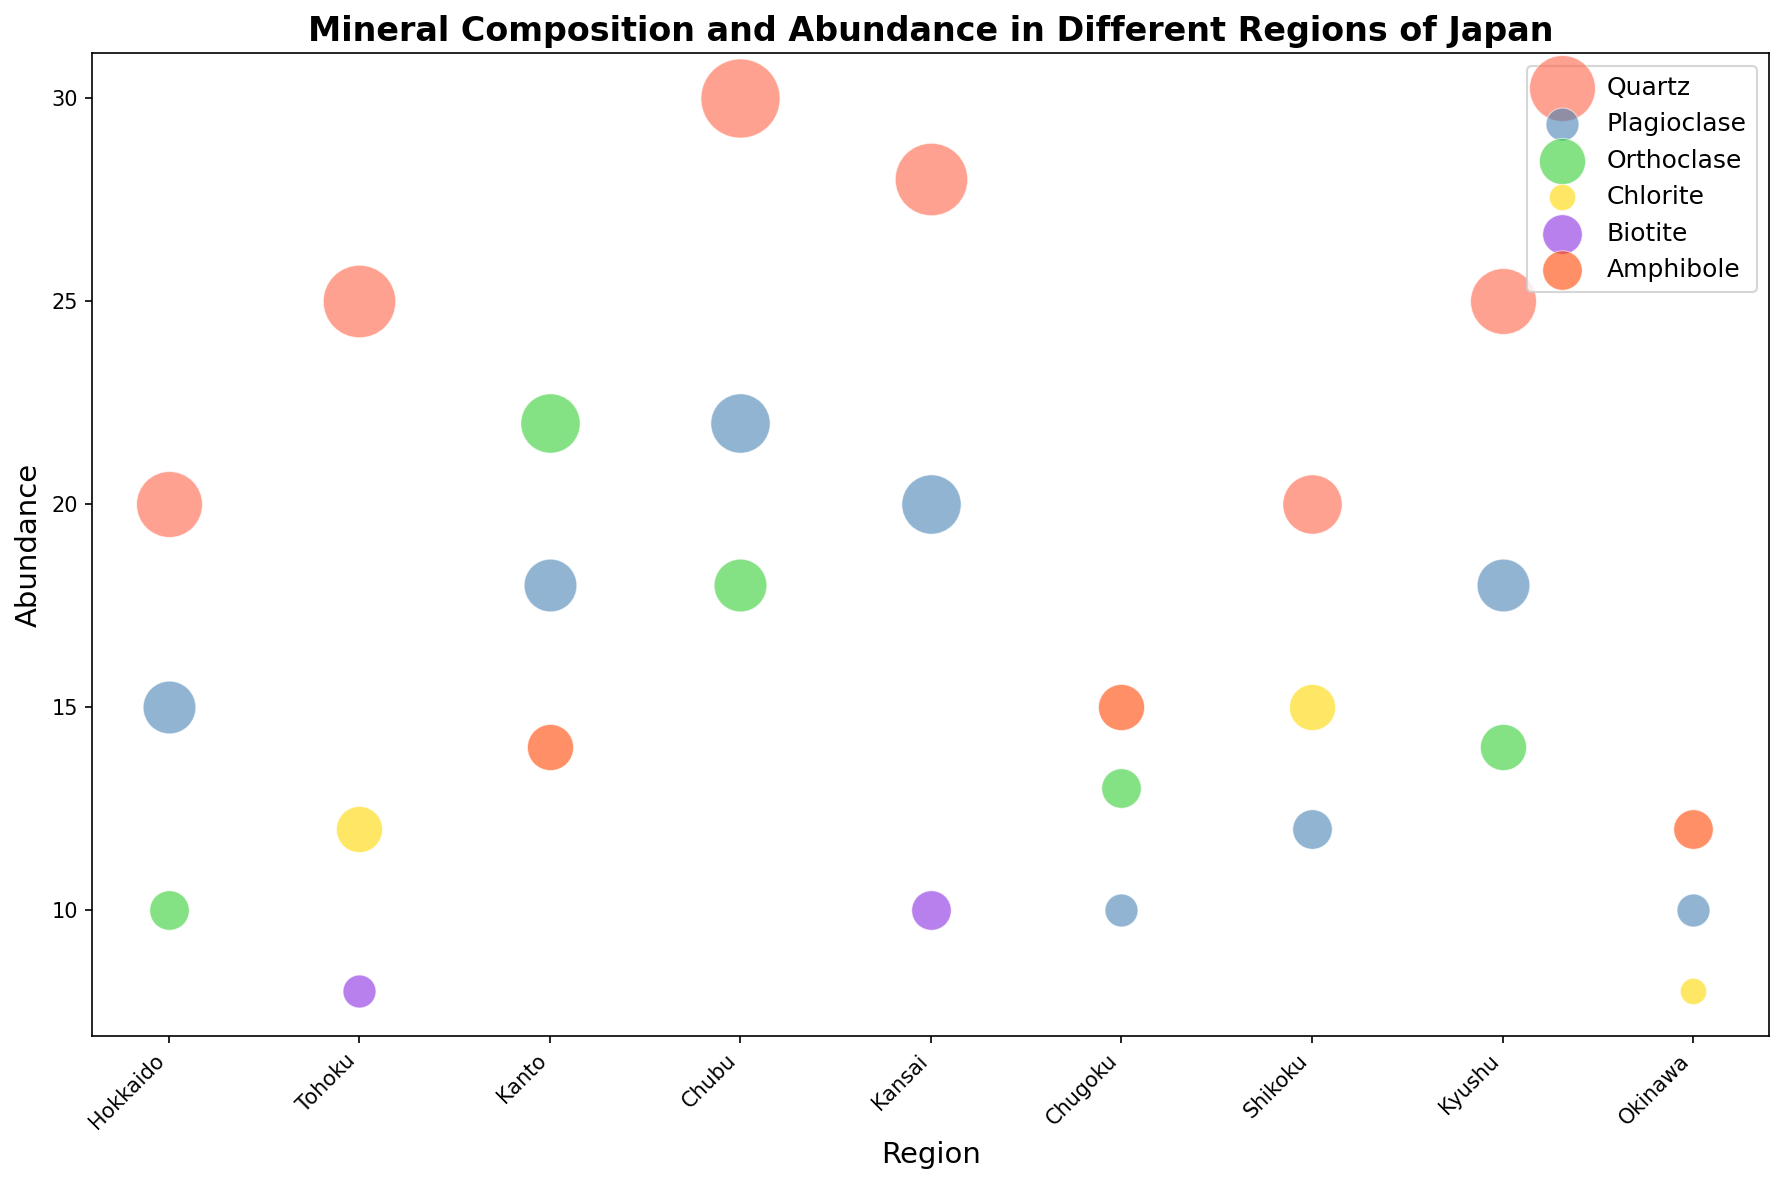Which region has the highest abundance of Quartz? Identify the data point with the highest value for Quartz. The highest is 30, and it is in the Chubu region.
Answer: Chubu Compare the abundance of Plagioclase in Hokkaido and Kanto. Which region has more? Hokkaido has an abundance of 15 for Plagioclase. Kanto has an abundance of 18 for Plagioclase. Therefore, Kanto has more Plagioclase.
Answer: Kanto What is the total abundance of all minerals in the Chugoku region? Sum the abundance values for all minerals in Chugoku: Amphibole (15), Orthoclase (13), and Plagioclase (10). 15 + 13 + 10 = 38.
Answer: 38 Which mineral is represented by red bubbles, and in which regions is it found? Red bubbles represent Quartz. Quartz is found in Hokkaido, Tohoku, Chubu, Kansai, Shikoku, and Kyushu.
Answer: Quartz, Hokkaido, Tohoku, Chubu, Kansai, Shikoku, Kyushu Is the abundance of Orthoclase greater in Kanto or Chubu? Kanto has an abundance of 22 for Orthoclase, while Chubu has an abundance of 18. Hence, Orthoclase is more abundant in Kanto.
Answer: Kanto How does the abundance of Biotite in Tohoku compare to that in Kansai? Tohoku has an abundance of 8 for Biotite, and Kansai has an abundance of 10 for Biotite. Therefore, Biotite is more abundant in Kansai.
Answer: Kansai What is the average abundance of all minerals in Hokkaido? Sum the abundance of all minerals in Hokkaido (20 for Quartz, 15 for Plagioclase, 10 for Orthoclase) and divide by the number of minerals: (20 + 15 + 10) / 3 = 15.
Answer: 15 Which mineral is least represented in Okinawa, and what is its abundance? The least represented mineral in Okinawa is Chlorite with an abundance of 8.
Answer: Chlorite, 8 Compare the abundance of Amphibole in Chugoku and Okinawa. Which region has more Amphibole? Chugoku has an abundance of 15 for Amphibole, and Okinawa has an abundance of 12. Therefore, Chugoku has more Amphibole.
Answer: Chugoku 